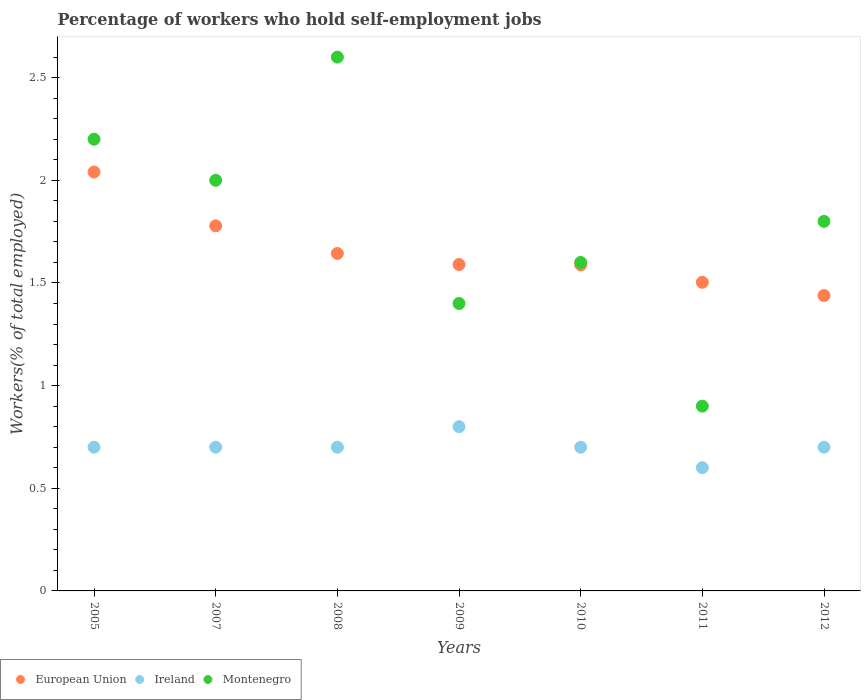What is the percentage of self-employed workers in European Union in 2008?
Your response must be concise. 1.64. Across all years, what is the maximum percentage of self-employed workers in Ireland?
Your answer should be very brief. 0.8. Across all years, what is the minimum percentage of self-employed workers in Montenegro?
Give a very brief answer. 0.9. In which year was the percentage of self-employed workers in Ireland minimum?
Give a very brief answer. 2011. What is the total percentage of self-employed workers in European Union in the graph?
Keep it short and to the point. 11.58. What is the difference between the percentage of self-employed workers in Montenegro in 2009 and that in 2011?
Provide a short and direct response. 0.5. What is the difference between the percentage of self-employed workers in Ireland in 2011 and the percentage of self-employed workers in European Union in 2008?
Keep it short and to the point. -1.04. What is the average percentage of self-employed workers in Ireland per year?
Offer a very short reply. 0.7. In the year 2007, what is the difference between the percentage of self-employed workers in Montenegro and percentage of self-employed workers in European Union?
Offer a very short reply. 0.22. In how many years, is the percentage of self-employed workers in European Union greater than 2.4 %?
Ensure brevity in your answer.  0. What is the ratio of the percentage of self-employed workers in Montenegro in 2008 to that in 2010?
Ensure brevity in your answer.  1.62. Is the difference between the percentage of self-employed workers in Montenegro in 2005 and 2012 greater than the difference between the percentage of self-employed workers in European Union in 2005 and 2012?
Give a very brief answer. No. What is the difference between the highest and the second highest percentage of self-employed workers in European Union?
Keep it short and to the point. 0.26. What is the difference between the highest and the lowest percentage of self-employed workers in Ireland?
Offer a terse response. 0.2. Is the percentage of self-employed workers in European Union strictly greater than the percentage of self-employed workers in Ireland over the years?
Your answer should be very brief. Yes. How many years are there in the graph?
Provide a short and direct response. 7. What is the difference between two consecutive major ticks on the Y-axis?
Make the answer very short. 0.5. Are the values on the major ticks of Y-axis written in scientific E-notation?
Make the answer very short. No. Does the graph contain any zero values?
Provide a succinct answer. No. How many legend labels are there?
Offer a very short reply. 3. What is the title of the graph?
Keep it short and to the point. Percentage of workers who hold self-employment jobs. What is the label or title of the X-axis?
Keep it short and to the point. Years. What is the label or title of the Y-axis?
Give a very brief answer. Workers(% of total employed). What is the Workers(% of total employed) of European Union in 2005?
Offer a very short reply. 2.04. What is the Workers(% of total employed) of Ireland in 2005?
Your answer should be very brief. 0.7. What is the Workers(% of total employed) in Montenegro in 2005?
Keep it short and to the point. 2.2. What is the Workers(% of total employed) in European Union in 2007?
Provide a succinct answer. 1.78. What is the Workers(% of total employed) of Ireland in 2007?
Provide a succinct answer. 0.7. What is the Workers(% of total employed) in European Union in 2008?
Offer a very short reply. 1.64. What is the Workers(% of total employed) of Ireland in 2008?
Ensure brevity in your answer.  0.7. What is the Workers(% of total employed) in Montenegro in 2008?
Provide a short and direct response. 2.6. What is the Workers(% of total employed) in European Union in 2009?
Your answer should be compact. 1.59. What is the Workers(% of total employed) in Ireland in 2009?
Ensure brevity in your answer.  0.8. What is the Workers(% of total employed) in Montenegro in 2009?
Keep it short and to the point. 1.4. What is the Workers(% of total employed) of European Union in 2010?
Your response must be concise. 1.59. What is the Workers(% of total employed) in Ireland in 2010?
Provide a succinct answer. 0.7. What is the Workers(% of total employed) of Montenegro in 2010?
Keep it short and to the point. 1.6. What is the Workers(% of total employed) in European Union in 2011?
Provide a succinct answer. 1.5. What is the Workers(% of total employed) of Ireland in 2011?
Your answer should be very brief. 0.6. What is the Workers(% of total employed) of Montenegro in 2011?
Offer a very short reply. 0.9. What is the Workers(% of total employed) of European Union in 2012?
Keep it short and to the point. 1.44. What is the Workers(% of total employed) of Ireland in 2012?
Provide a short and direct response. 0.7. What is the Workers(% of total employed) of Montenegro in 2012?
Provide a succinct answer. 1.8. Across all years, what is the maximum Workers(% of total employed) in European Union?
Your answer should be very brief. 2.04. Across all years, what is the maximum Workers(% of total employed) in Ireland?
Your answer should be compact. 0.8. Across all years, what is the maximum Workers(% of total employed) of Montenegro?
Give a very brief answer. 2.6. Across all years, what is the minimum Workers(% of total employed) of European Union?
Your answer should be very brief. 1.44. Across all years, what is the minimum Workers(% of total employed) in Ireland?
Provide a short and direct response. 0.6. Across all years, what is the minimum Workers(% of total employed) in Montenegro?
Keep it short and to the point. 0.9. What is the total Workers(% of total employed) of European Union in the graph?
Make the answer very short. 11.58. What is the difference between the Workers(% of total employed) in European Union in 2005 and that in 2007?
Give a very brief answer. 0.26. What is the difference between the Workers(% of total employed) in Ireland in 2005 and that in 2007?
Your answer should be very brief. 0. What is the difference between the Workers(% of total employed) of Montenegro in 2005 and that in 2007?
Your answer should be very brief. 0.2. What is the difference between the Workers(% of total employed) in European Union in 2005 and that in 2008?
Your answer should be very brief. 0.4. What is the difference between the Workers(% of total employed) in Montenegro in 2005 and that in 2008?
Provide a succinct answer. -0.4. What is the difference between the Workers(% of total employed) in European Union in 2005 and that in 2009?
Provide a succinct answer. 0.45. What is the difference between the Workers(% of total employed) of Montenegro in 2005 and that in 2009?
Keep it short and to the point. 0.8. What is the difference between the Workers(% of total employed) of European Union in 2005 and that in 2010?
Your response must be concise. 0.45. What is the difference between the Workers(% of total employed) in European Union in 2005 and that in 2011?
Offer a very short reply. 0.54. What is the difference between the Workers(% of total employed) of Ireland in 2005 and that in 2011?
Keep it short and to the point. 0.1. What is the difference between the Workers(% of total employed) of Montenegro in 2005 and that in 2011?
Your response must be concise. 1.3. What is the difference between the Workers(% of total employed) in European Union in 2005 and that in 2012?
Provide a succinct answer. 0.6. What is the difference between the Workers(% of total employed) of European Union in 2007 and that in 2008?
Give a very brief answer. 0.13. What is the difference between the Workers(% of total employed) in European Union in 2007 and that in 2009?
Give a very brief answer. 0.19. What is the difference between the Workers(% of total employed) of Ireland in 2007 and that in 2009?
Your answer should be compact. -0.1. What is the difference between the Workers(% of total employed) in Montenegro in 2007 and that in 2009?
Your answer should be compact. 0.6. What is the difference between the Workers(% of total employed) of European Union in 2007 and that in 2010?
Provide a succinct answer. 0.19. What is the difference between the Workers(% of total employed) in Montenegro in 2007 and that in 2010?
Offer a terse response. 0.4. What is the difference between the Workers(% of total employed) of European Union in 2007 and that in 2011?
Provide a short and direct response. 0.28. What is the difference between the Workers(% of total employed) of Montenegro in 2007 and that in 2011?
Make the answer very short. 1.1. What is the difference between the Workers(% of total employed) in European Union in 2007 and that in 2012?
Provide a succinct answer. 0.34. What is the difference between the Workers(% of total employed) in Ireland in 2007 and that in 2012?
Provide a short and direct response. 0. What is the difference between the Workers(% of total employed) of European Union in 2008 and that in 2009?
Ensure brevity in your answer.  0.05. What is the difference between the Workers(% of total employed) in Ireland in 2008 and that in 2009?
Offer a very short reply. -0.1. What is the difference between the Workers(% of total employed) of European Union in 2008 and that in 2010?
Offer a very short reply. 0.06. What is the difference between the Workers(% of total employed) in Ireland in 2008 and that in 2010?
Your answer should be compact. 0. What is the difference between the Workers(% of total employed) in Montenegro in 2008 and that in 2010?
Give a very brief answer. 1. What is the difference between the Workers(% of total employed) in European Union in 2008 and that in 2011?
Keep it short and to the point. 0.14. What is the difference between the Workers(% of total employed) of Ireland in 2008 and that in 2011?
Make the answer very short. 0.1. What is the difference between the Workers(% of total employed) of European Union in 2008 and that in 2012?
Provide a short and direct response. 0.2. What is the difference between the Workers(% of total employed) of Montenegro in 2008 and that in 2012?
Provide a succinct answer. 0.8. What is the difference between the Workers(% of total employed) of European Union in 2009 and that in 2010?
Make the answer very short. 0. What is the difference between the Workers(% of total employed) of Ireland in 2009 and that in 2010?
Offer a very short reply. 0.1. What is the difference between the Workers(% of total employed) of European Union in 2009 and that in 2011?
Ensure brevity in your answer.  0.09. What is the difference between the Workers(% of total employed) of Montenegro in 2009 and that in 2011?
Offer a terse response. 0.5. What is the difference between the Workers(% of total employed) in European Union in 2009 and that in 2012?
Keep it short and to the point. 0.15. What is the difference between the Workers(% of total employed) of Ireland in 2009 and that in 2012?
Keep it short and to the point. 0.1. What is the difference between the Workers(% of total employed) in European Union in 2010 and that in 2011?
Provide a succinct answer. 0.09. What is the difference between the Workers(% of total employed) in Ireland in 2010 and that in 2011?
Provide a short and direct response. 0.1. What is the difference between the Workers(% of total employed) in Montenegro in 2010 and that in 2011?
Offer a very short reply. 0.7. What is the difference between the Workers(% of total employed) of European Union in 2010 and that in 2012?
Offer a very short reply. 0.15. What is the difference between the Workers(% of total employed) of Ireland in 2010 and that in 2012?
Ensure brevity in your answer.  0. What is the difference between the Workers(% of total employed) of Montenegro in 2010 and that in 2012?
Ensure brevity in your answer.  -0.2. What is the difference between the Workers(% of total employed) of European Union in 2011 and that in 2012?
Ensure brevity in your answer.  0.06. What is the difference between the Workers(% of total employed) of Ireland in 2011 and that in 2012?
Provide a short and direct response. -0.1. What is the difference between the Workers(% of total employed) in European Union in 2005 and the Workers(% of total employed) in Ireland in 2007?
Ensure brevity in your answer.  1.34. What is the difference between the Workers(% of total employed) of European Union in 2005 and the Workers(% of total employed) of Montenegro in 2007?
Your answer should be very brief. 0.04. What is the difference between the Workers(% of total employed) in Ireland in 2005 and the Workers(% of total employed) in Montenegro in 2007?
Your answer should be very brief. -1.3. What is the difference between the Workers(% of total employed) of European Union in 2005 and the Workers(% of total employed) of Ireland in 2008?
Provide a succinct answer. 1.34. What is the difference between the Workers(% of total employed) of European Union in 2005 and the Workers(% of total employed) of Montenegro in 2008?
Provide a succinct answer. -0.56. What is the difference between the Workers(% of total employed) of European Union in 2005 and the Workers(% of total employed) of Ireland in 2009?
Offer a terse response. 1.24. What is the difference between the Workers(% of total employed) in European Union in 2005 and the Workers(% of total employed) in Montenegro in 2009?
Provide a short and direct response. 0.64. What is the difference between the Workers(% of total employed) of Ireland in 2005 and the Workers(% of total employed) of Montenegro in 2009?
Provide a succinct answer. -0.7. What is the difference between the Workers(% of total employed) of European Union in 2005 and the Workers(% of total employed) of Ireland in 2010?
Your answer should be compact. 1.34. What is the difference between the Workers(% of total employed) in European Union in 2005 and the Workers(% of total employed) in Montenegro in 2010?
Make the answer very short. 0.44. What is the difference between the Workers(% of total employed) of European Union in 2005 and the Workers(% of total employed) of Ireland in 2011?
Provide a succinct answer. 1.44. What is the difference between the Workers(% of total employed) of European Union in 2005 and the Workers(% of total employed) of Montenegro in 2011?
Keep it short and to the point. 1.14. What is the difference between the Workers(% of total employed) of Ireland in 2005 and the Workers(% of total employed) of Montenegro in 2011?
Make the answer very short. -0.2. What is the difference between the Workers(% of total employed) of European Union in 2005 and the Workers(% of total employed) of Ireland in 2012?
Provide a short and direct response. 1.34. What is the difference between the Workers(% of total employed) in European Union in 2005 and the Workers(% of total employed) in Montenegro in 2012?
Provide a succinct answer. 0.24. What is the difference between the Workers(% of total employed) in Ireland in 2005 and the Workers(% of total employed) in Montenegro in 2012?
Provide a short and direct response. -1.1. What is the difference between the Workers(% of total employed) of European Union in 2007 and the Workers(% of total employed) of Ireland in 2008?
Provide a succinct answer. 1.08. What is the difference between the Workers(% of total employed) of European Union in 2007 and the Workers(% of total employed) of Montenegro in 2008?
Offer a terse response. -0.82. What is the difference between the Workers(% of total employed) of European Union in 2007 and the Workers(% of total employed) of Ireland in 2009?
Offer a terse response. 0.98. What is the difference between the Workers(% of total employed) in European Union in 2007 and the Workers(% of total employed) in Montenegro in 2009?
Give a very brief answer. 0.38. What is the difference between the Workers(% of total employed) in European Union in 2007 and the Workers(% of total employed) in Ireland in 2010?
Provide a short and direct response. 1.08. What is the difference between the Workers(% of total employed) in European Union in 2007 and the Workers(% of total employed) in Montenegro in 2010?
Give a very brief answer. 0.18. What is the difference between the Workers(% of total employed) of European Union in 2007 and the Workers(% of total employed) of Ireland in 2011?
Make the answer very short. 1.18. What is the difference between the Workers(% of total employed) of European Union in 2007 and the Workers(% of total employed) of Montenegro in 2011?
Provide a succinct answer. 0.88. What is the difference between the Workers(% of total employed) in Ireland in 2007 and the Workers(% of total employed) in Montenegro in 2011?
Offer a very short reply. -0.2. What is the difference between the Workers(% of total employed) in European Union in 2007 and the Workers(% of total employed) in Ireland in 2012?
Your response must be concise. 1.08. What is the difference between the Workers(% of total employed) of European Union in 2007 and the Workers(% of total employed) of Montenegro in 2012?
Ensure brevity in your answer.  -0.02. What is the difference between the Workers(% of total employed) in European Union in 2008 and the Workers(% of total employed) in Ireland in 2009?
Your response must be concise. 0.84. What is the difference between the Workers(% of total employed) in European Union in 2008 and the Workers(% of total employed) in Montenegro in 2009?
Ensure brevity in your answer.  0.24. What is the difference between the Workers(% of total employed) in Ireland in 2008 and the Workers(% of total employed) in Montenegro in 2009?
Provide a short and direct response. -0.7. What is the difference between the Workers(% of total employed) of European Union in 2008 and the Workers(% of total employed) of Ireland in 2010?
Make the answer very short. 0.94. What is the difference between the Workers(% of total employed) of European Union in 2008 and the Workers(% of total employed) of Montenegro in 2010?
Keep it short and to the point. 0.04. What is the difference between the Workers(% of total employed) of Ireland in 2008 and the Workers(% of total employed) of Montenegro in 2010?
Give a very brief answer. -0.9. What is the difference between the Workers(% of total employed) in European Union in 2008 and the Workers(% of total employed) in Ireland in 2011?
Offer a very short reply. 1.04. What is the difference between the Workers(% of total employed) of European Union in 2008 and the Workers(% of total employed) of Montenegro in 2011?
Make the answer very short. 0.74. What is the difference between the Workers(% of total employed) of European Union in 2008 and the Workers(% of total employed) of Ireland in 2012?
Your response must be concise. 0.94. What is the difference between the Workers(% of total employed) in European Union in 2008 and the Workers(% of total employed) in Montenegro in 2012?
Provide a succinct answer. -0.16. What is the difference between the Workers(% of total employed) of European Union in 2009 and the Workers(% of total employed) of Ireland in 2010?
Your answer should be very brief. 0.89. What is the difference between the Workers(% of total employed) of European Union in 2009 and the Workers(% of total employed) of Montenegro in 2010?
Keep it short and to the point. -0.01. What is the difference between the Workers(% of total employed) of Ireland in 2009 and the Workers(% of total employed) of Montenegro in 2010?
Make the answer very short. -0.8. What is the difference between the Workers(% of total employed) of European Union in 2009 and the Workers(% of total employed) of Montenegro in 2011?
Offer a very short reply. 0.69. What is the difference between the Workers(% of total employed) of European Union in 2009 and the Workers(% of total employed) of Ireland in 2012?
Make the answer very short. 0.89. What is the difference between the Workers(% of total employed) of European Union in 2009 and the Workers(% of total employed) of Montenegro in 2012?
Offer a terse response. -0.21. What is the difference between the Workers(% of total employed) of European Union in 2010 and the Workers(% of total employed) of Ireland in 2011?
Your response must be concise. 0.99. What is the difference between the Workers(% of total employed) in European Union in 2010 and the Workers(% of total employed) in Montenegro in 2011?
Your answer should be compact. 0.69. What is the difference between the Workers(% of total employed) of European Union in 2010 and the Workers(% of total employed) of Ireland in 2012?
Make the answer very short. 0.89. What is the difference between the Workers(% of total employed) of European Union in 2010 and the Workers(% of total employed) of Montenegro in 2012?
Provide a short and direct response. -0.21. What is the difference between the Workers(% of total employed) of Ireland in 2010 and the Workers(% of total employed) of Montenegro in 2012?
Keep it short and to the point. -1.1. What is the difference between the Workers(% of total employed) in European Union in 2011 and the Workers(% of total employed) in Ireland in 2012?
Give a very brief answer. 0.8. What is the difference between the Workers(% of total employed) in European Union in 2011 and the Workers(% of total employed) in Montenegro in 2012?
Ensure brevity in your answer.  -0.3. What is the difference between the Workers(% of total employed) in Ireland in 2011 and the Workers(% of total employed) in Montenegro in 2012?
Make the answer very short. -1.2. What is the average Workers(% of total employed) of European Union per year?
Offer a terse response. 1.65. What is the average Workers(% of total employed) of Montenegro per year?
Your answer should be very brief. 1.79. In the year 2005, what is the difference between the Workers(% of total employed) of European Union and Workers(% of total employed) of Ireland?
Keep it short and to the point. 1.34. In the year 2005, what is the difference between the Workers(% of total employed) of European Union and Workers(% of total employed) of Montenegro?
Offer a terse response. -0.16. In the year 2007, what is the difference between the Workers(% of total employed) of European Union and Workers(% of total employed) of Ireland?
Give a very brief answer. 1.08. In the year 2007, what is the difference between the Workers(% of total employed) in European Union and Workers(% of total employed) in Montenegro?
Keep it short and to the point. -0.22. In the year 2007, what is the difference between the Workers(% of total employed) in Ireland and Workers(% of total employed) in Montenegro?
Give a very brief answer. -1.3. In the year 2008, what is the difference between the Workers(% of total employed) of European Union and Workers(% of total employed) of Ireland?
Your response must be concise. 0.94. In the year 2008, what is the difference between the Workers(% of total employed) of European Union and Workers(% of total employed) of Montenegro?
Your answer should be compact. -0.96. In the year 2009, what is the difference between the Workers(% of total employed) in European Union and Workers(% of total employed) in Ireland?
Provide a short and direct response. 0.79. In the year 2009, what is the difference between the Workers(% of total employed) of European Union and Workers(% of total employed) of Montenegro?
Your response must be concise. 0.19. In the year 2010, what is the difference between the Workers(% of total employed) of European Union and Workers(% of total employed) of Ireland?
Your response must be concise. 0.89. In the year 2010, what is the difference between the Workers(% of total employed) of European Union and Workers(% of total employed) of Montenegro?
Your answer should be very brief. -0.01. In the year 2011, what is the difference between the Workers(% of total employed) of European Union and Workers(% of total employed) of Ireland?
Your answer should be compact. 0.9. In the year 2011, what is the difference between the Workers(% of total employed) of European Union and Workers(% of total employed) of Montenegro?
Your answer should be compact. 0.6. In the year 2012, what is the difference between the Workers(% of total employed) in European Union and Workers(% of total employed) in Ireland?
Your response must be concise. 0.74. In the year 2012, what is the difference between the Workers(% of total employed) of European Union and Workers(% of total employed) of Montenegro?
Offer a terse response. -0.36. What is the ratio of the Workers(% of total employed) in European Union in 2005 to that in 2007?
Give a very brief answer. 1.15. What is the ratio of the Workers(% of total employed) in European Union in 2005 to that in 2008?
Provide a succinct answer. 1.24. What is the ratio of the Workers(% of total employed) in Montenegro in 2005 to that in 2008?
Your answer should be compact. 0.85. What is the ratio of the Workers(% of total employed) of European Union in 2005 to that in 2009?
Offer a terse response. 1.28. What is the ratio of the Workers(% of total employed) of Ireland in 2005 to that in 2009?
Your answer should be very brief. 0.88. What is the ratio of the Workers(% of total employed) in Montenegro in 2005 to that in 2009?
Provide a short and direct response. 1.57. What is the ratio of the Workers(% of total employed) in European Union in 2005 to that in 2010?
Offer a very short reply. 1.28. What is the ratio of the Workers(% of total employed) in Montenegro in 2005 to that in 2010?
Your response must be concise. 1.38. What is the ratio of the Workers(% of total employed) of European Union in 2005 to that in 2011?
Keep it short and to the point. 1.36. What is the ratio of the Workers(% of total employed) in Ireland in 2005 to that in 2011?
Provide a short and direct response. 1.17. What is the ratio of the Workers(% of total employed) of Montenegro in 2005 to that in 2011?
Ensure brevity in your answer.  2.44. What is the ratio of the Workers(% of total employed) of European Union in 2005 to that in 2012?
Ensure brevity in your answer.  1.42. What is the ratio of the Workers(% of total employed) of Ireland in 2005 to that in 2012?
Ensure brevity in your answer.  1. What is the ratio of the Workers(% of total employed) of Montenegro in 2005 to that in 2012?
Your response must be concise. 1.22. What is the ratio of the Workers(% of total employed) of European Union in 2007 to that in 2008?
Your response must be concise. 1.08. What is the ratio of the Workers(% of total employed) in Ireland in 2007 to that in 2008?
Provide a short and direct response. 1. What is the ratio of the Workers(% of total employed) of Montenegro in 2007 to that in 2008?
Offer a terse response. 0.77. What is the ratio of the Workers(% of total employed) in European Union in 2007 to that in 2009?
Make the answer very short. 1.12. What is the ratio of the Workers(% of total employed) of Ireland in 2007 to that in 2009?
Your response must be concise. 0.88. What is the ratio of the Workers(% of total employed) in Montenegro in 2007 to that in 2009?
Your answer should be compact. 1.43. What is the ratio of the Workers(% of total employed) in European Union in 2007 to that in 2010?
Ensure brevity in your answer.  1.12. What is the ratio of the Workers(% of total employed) of European Union in 2007 to that in 2011?
Offer a terse response. 1.18. What is the ratio of the Workers(% of total employed) of Montenegro in 2007 to that in 2011?
Your answer should be very brief. 2.22. What is the ratio of the Workers(% of total employed) of European Union in 2007 to that in 2012?
Provide a short and direct response. 1.24. What is the ratio of the Workers(% of total employed) of European Union in 2008 to that in 2009?
Offer a terse response. 1.03. What is the ratio of the Workers(% of total employed) in Montenegro in 2008 to that in 2009?
Your answer should be very brief. 1.86. What is the ratio of the Workers(% of total employed) in European Union in 2008 to that in 2010?
Keep it short and to the point. 1.03. What is the ratio of the Workers(% of total employed) in Montenegro in 2008 to that in 2010?
Your response must be concise. 1.62. What is the ratio of the Workers(% of total employed) of European Union in 2008 to that in 2011?
Make the answer very short. 1.09. What is the ratio of the Workers(% of total employed) of Ireland in 2008 to that in 2011?
Offer a terse response. 1.17. What is the ratio of the Workers(% of total employed) of Montenegro in 2008 to that in 2011?
Provide a succinct answer. 2.89. What is the ratio of the Workers(% of total employed) in European Union in 2008 to that in 2012?
Your answer should be very brief. 1.14. What is the ratio of the Workers(% of total employed) of Montenegro in 2008 to that in 2012?
Your answer should be very brief. 1.44. What is the ratio of the Workers(% of total employed) in European Union in 2009 to that in 2010?
Keep it short and to the point. 1. What is the ratio of the Workers(% of total employed) of Montenegro in 2009 to that in 2010?
Offer a terse response. 0.88. What is the ratio of the Workers(% of total employed) in European Union in 2009 to that in 2011?
Your response must be concise. 1.06. What is the ratio of the Workers(% of total employed) in Ireland in 2009 to that in 2011?
Your answer should be very brief. 1.33. What is the ratio of the Workers(% of total employed) of Montenegro in 2009 to that in 2011?
Keep it short and to the point. 1.56. What is the ratio of the Workers(% of total employed) in European Union in 2009 to that in 2012?
Make the answer very short. 1.1. What is the ratio of the Workers(% of total employed) of Ireland in 2009 to that in 2012?
Keep it short and to the point. 1.14. What is the ratio of the Workers(% of total employed) of Montenegro in 2009 to that in 2012?
Your answer should be compact. 0.78. What is the ratio of the Workers(% of total employed) in European Union in 2010 to that in 2011?
Provide a short and direct response. 1.06. What is the ratio of the Workers(% of total employed) of Montenegro in 2010 to that in 2011?
Offer a very short reply. 1.78. What is the ratio of the Workers(% of total employed) in European Union in 2010 to that in 2012?
Provide a short and direct response. 1.1. What is the ratio of the Workers(% of total employed) of Ireland in 2010 to that in 2012?
Make the answer very short. 1. What is the ratio of the Workers(% of total employed) of Montenegro in 2010 to that in 2012?
Offer a terse response. 0.89. What is the ratio of the Workers(% of total employed) in European Union in 2011 to that in 2012?
Ensure brevity in your answer.  1.04. What is the ratio of the Workers(% of total employed) of Montenegro in 2011 to that in 2012?
Your response must be concise. 0.5. What is the difference between the highest and the second highest Workers(% of total employed) in European Union?
Your response must be concise. 0.26. What is the difference between the highest and the second highest Workers(% of total employed) of Montenegro?
Ensure brevity in your answer.  0.4. What is the difference between the highest and the lowest Workers(% of total employed) of European Union?
Offer a very short reply. 0.6. What is the difference between the highest and the lowest Workers(% of total employed) in Montenegro?
Keep it short and to the point. 1.7. 